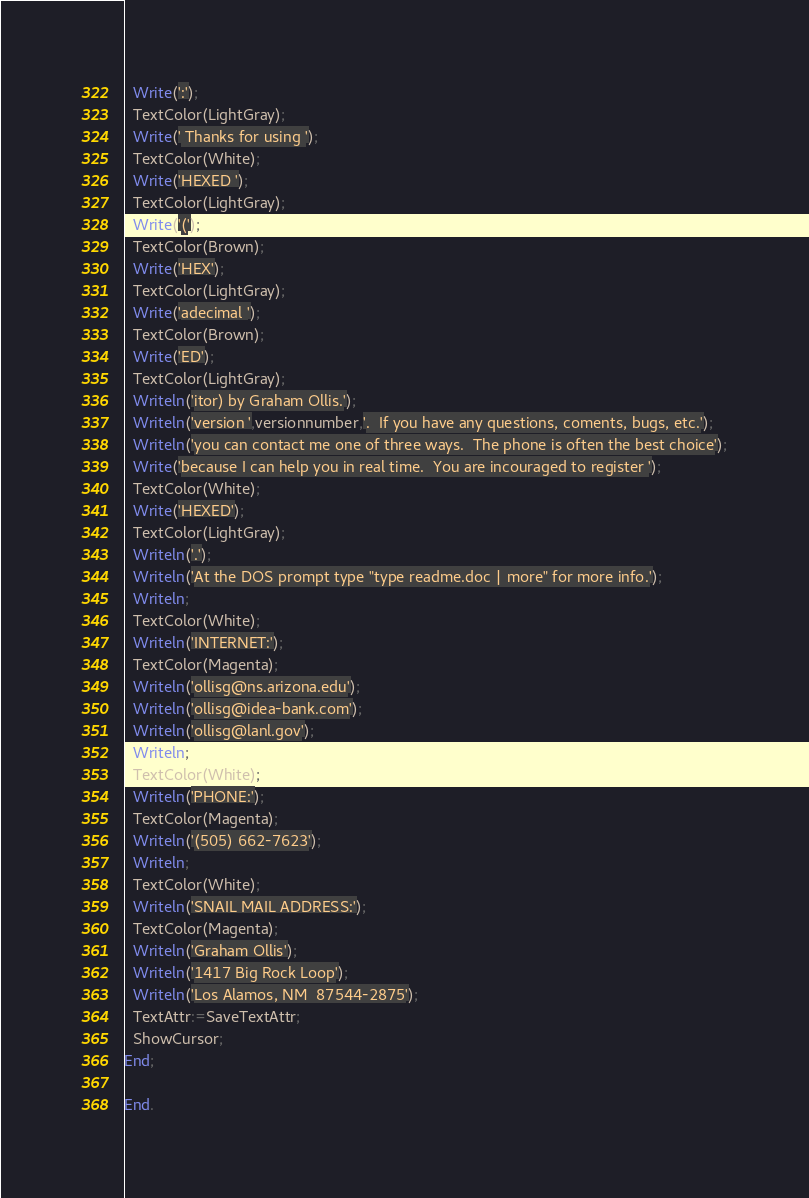<code> <loc_0><loc_0><loc_500><loc_500><_Pascal_>  Write(':');
  TextColor(LightGray);
  Write(' Thanks for using ');
  TextColor(White);
  Write('HEXED ');
  TextColor(LightGray);
  Write('(');
  TextColor(Brown);
  Write('HEX');
  TextColor(LightGray);
  Write('adecimal ');
  TextColor(Brown);
  Write('ED');
  TextColor(LightGray);
  Writeln('itor) by Graham Ollis.');
  Writeln('version ',versionnumber,'.  If you have any questions, coments, bugs, etc.');
  Writeln('you can contact me one of three ways.  The phone is often the best choice');
  Write('because I can help you in real time.  You are incouraged to register ');
  TextColor(White);
  Write('HEXED');
  TextColor(LightGray);
  Writeln('.');
  Writeln('At the DOS prompt type "type readme.doc | more" for more info.');
  Writeln;
  TextColor(White);
  Writeln('INTERNET:');
  TextColor(Magenta);
  Writeln('ollisg@ns.arizona.edu');
  Writeln('ollisg@idea-bank.com');
  Writeln('ollisg@lanl.gov');
  Writeln;
  TextColor(White);
  Writeln('PHONE:');
  TextColor(Magenta);
  Writeln('(505) 662-7623');
  Writeln;
  TextColor(White);
  Writeln('SNAIL MAIL ADDRESS:');
  TextColor(Magenta);
  Writeln('Graham Ollis');
  Writeln('1417 Big Rock Loop');
  Writeln('Los Alamos, NM  87544-2875');
  TextAttr:=SaveTextAttr;
  ShowCursor;
End;

End.
</code> 